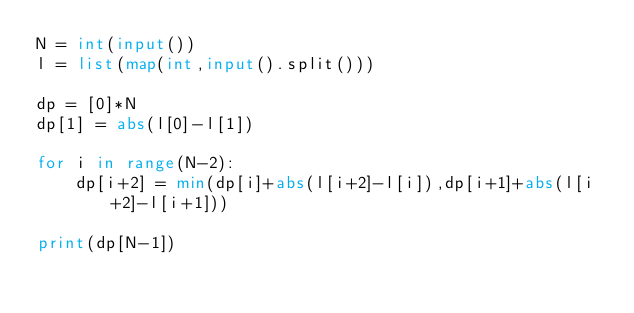Convert code to text. <code><loc_0><loc_0><loc_500><loc_500><_Python_>N = int(input())
l = list(map(int,input().split()))

dp = [0]*N
dp[1] = abs(l[0]-l[1])

for i in range(N-2):
    dp[i+2] = min(dp[i]+abs(l[i+2]-l[i]),dp[i+1]+abs(l[i+2]-l[i+1]))

print(dp[N-1])</code> 